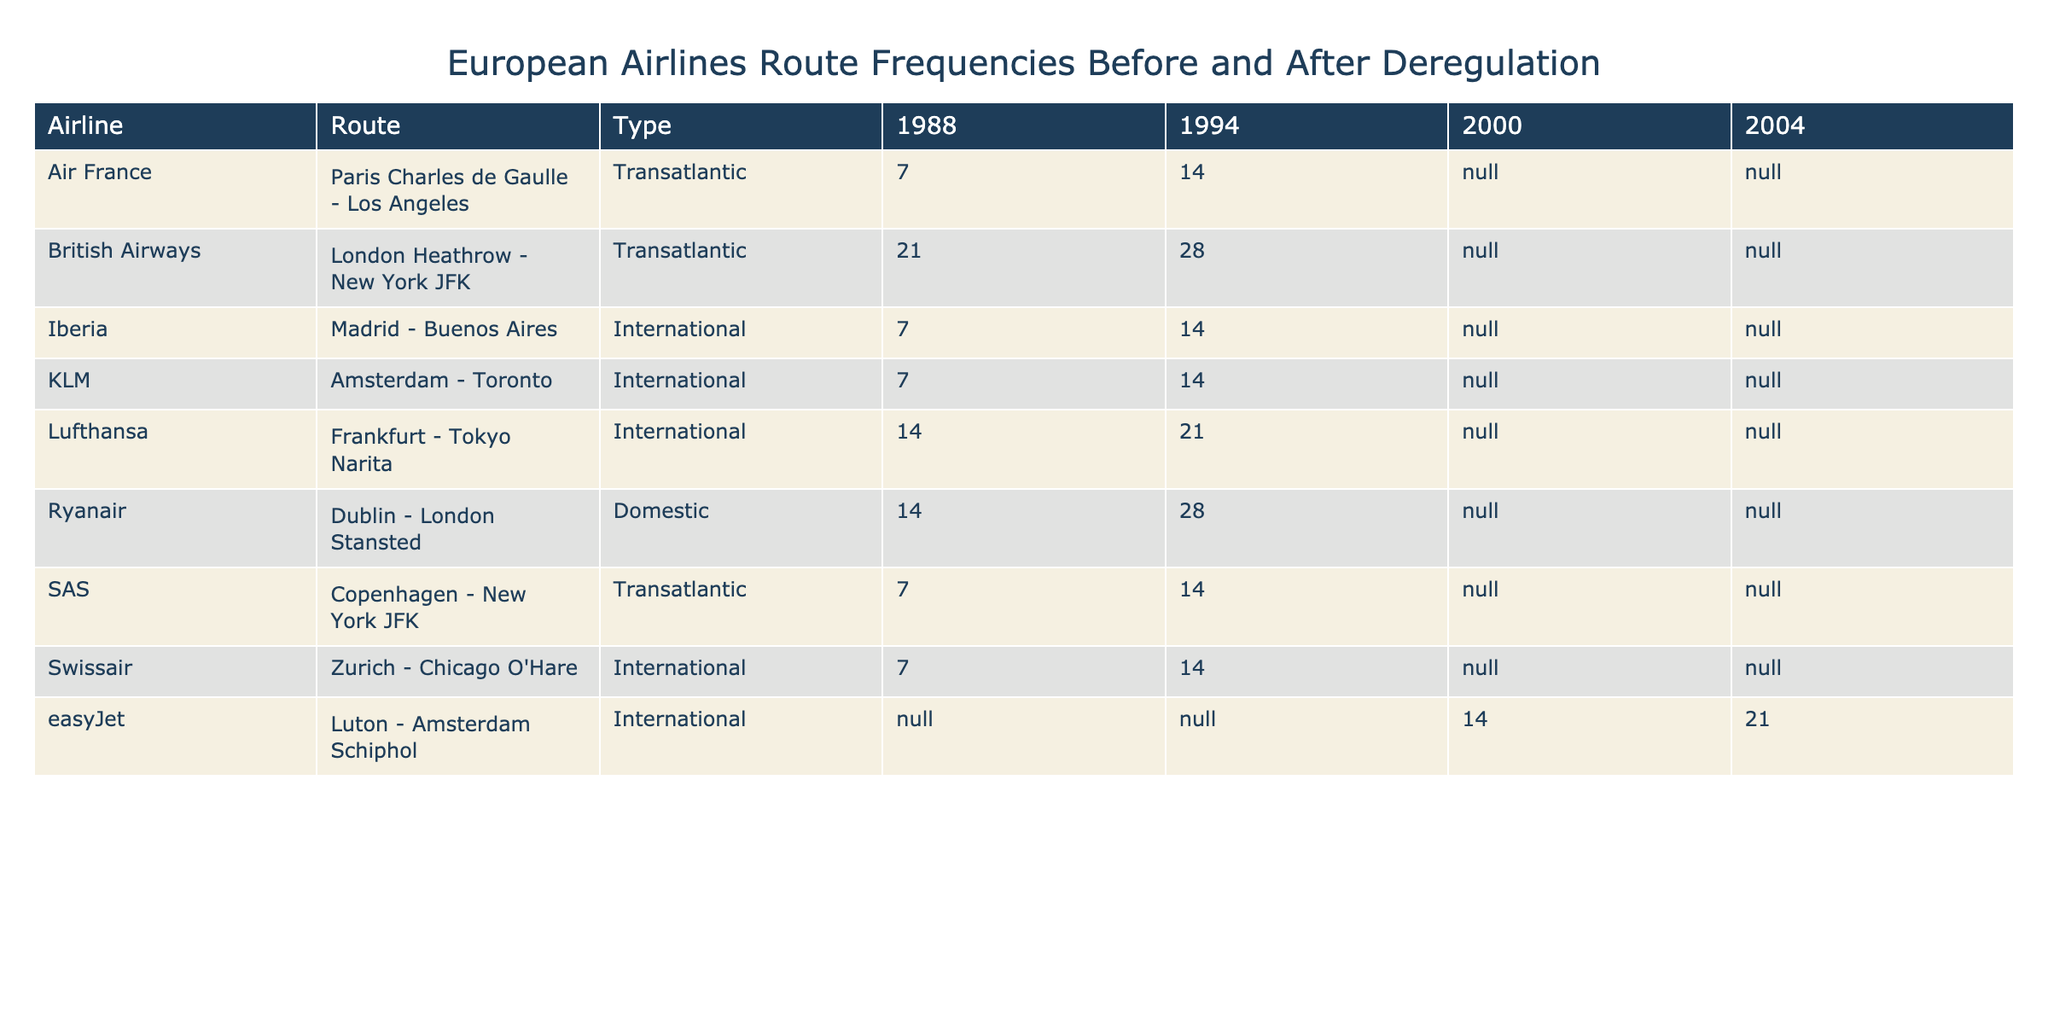What was the frequency of Lufthansa's Frankfurt to Tokyo route in 1994? The table shows the frequency for Lufthansa's Frankfurt - Tokyo Narita route in 1994 is listed directly under the 1994 column for that route, which indicates it had a frequency of 21 times per week.
Answer: 21 Which airline had the highest frequency on their transatlantic routes in 1994? In 1994, British Airways had the highest frequency on the London Heathrow - New York JFK route with 28 flights per week. SAS, Air France, and Iberia had lower frequencies.
Answer: British Airways Was there an increase in the frequency for Ryanair's Dublin to London Stansted route from 1988 to 1994? By looking at the table, Ryanair's frequency for the Dublin - London Stansted route increased from 14 in 1988 to 28 in 1994, indicating a definite increase.
Answer: Yes How many total international routes were listed for 1988? In 1988, the table lists specific routes for Lufthansa, Air France, KLM, Iberia, and Swissair under the International category, totaling 5 international routes.
Answer: 5 What was the frequency difference for British Airways' New York JFK route between 1988 and 1994? The frequency for British Airways' London Heathrow - New York JFK route increased from 21 in 1988 to 28 in 1994. The difference is 28 - 21 = 7.
Answer: 7 What was the average frequency of transatlantic routes for the year 1994 in the table? The transatlantic routes listed for 1994 are British Airways (28), SAS (14), and Air France (14). The average frequency is calculated as (28 + 14 + 14) / 3 = 18.67.
Answer: 18.67 Did easyJet operate any routes in 1988? The table shows there are no entries for easyJet in 1988, indicating that the airline did not operate any routes in that year.
Answer: No Which airline saw the most significant increase in frequency from 1988 to 1994? By comparing the frequency changes between 1988 and 1994, Ryanair's Dublin - London Stansted route saw an increase from 14 to 28, which is a change of 14. This was the largest increase among all airlines’ routes in that time period.
Answer: Ryanair What was the frequency of the Zurich to Chicago O'Hare route in both 1988 and 1994? The table shows that Swissair's Zurich - Chicago O'Hare route had a frequency of 7 in 1988 and 14 in 1994.
Answer: 7 in 1988 and 14 in 1994 How many transatlantic routes were listed for SAS in 1994? The table only lists one transatlantic route for SAS, which is the Copenhagen - New York JFK route.
Answer: 1 What was the trend in international route frequencies for KLM from 1988 to 1994? KLM's frequency for the Amsterdam - Toronto route increased from 7 in 1988 to 14 in 1994, indicating a trend of growth in international route frequencies during that period.
Answer: Increase 